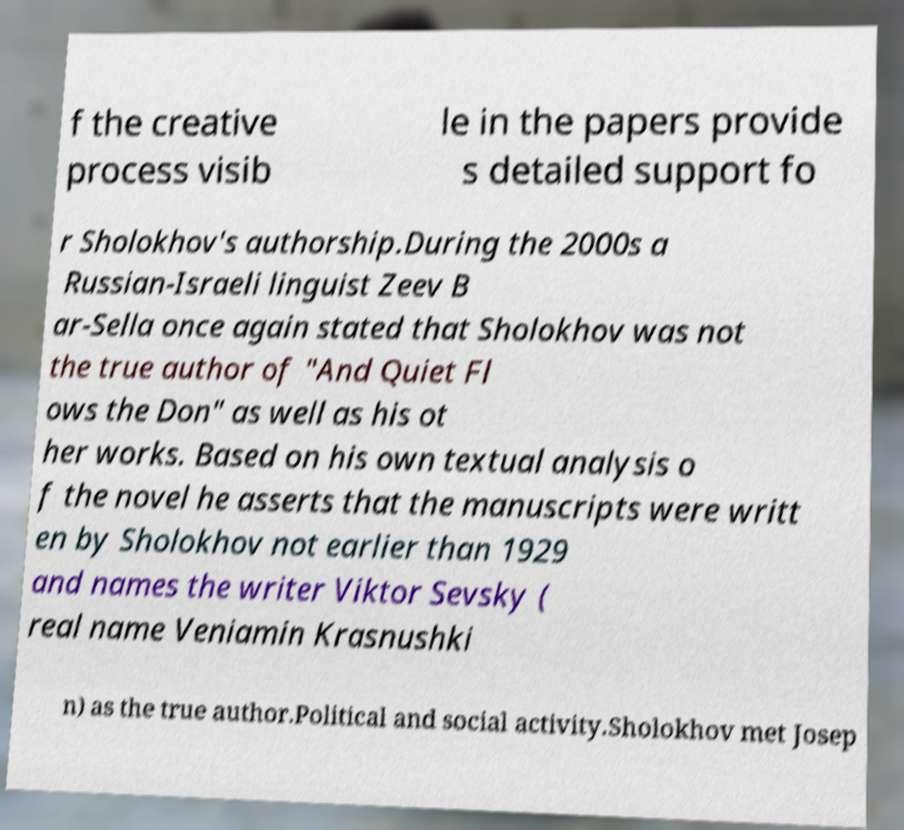Could you extract and type out the text from this image? f the creative process visib le in the papers provide s detailed support fo r Sholokhov's authorship.During the 2000s a Russian-Israeli linguist Zeev B ar-Sella once again stated that Sholokhov was not the true author of "And Quiet Fl ows the Don" as well as his ot her works. Based on his own textual analysis o f the novel he asserts that the manuscripts were writt en by Sholokhov not earlier than 1929 and names the writer Viktor Sevsky ( real name Veniamin Krasnushki n) as the true author.Political and social activity.Sholokhov met Josep 